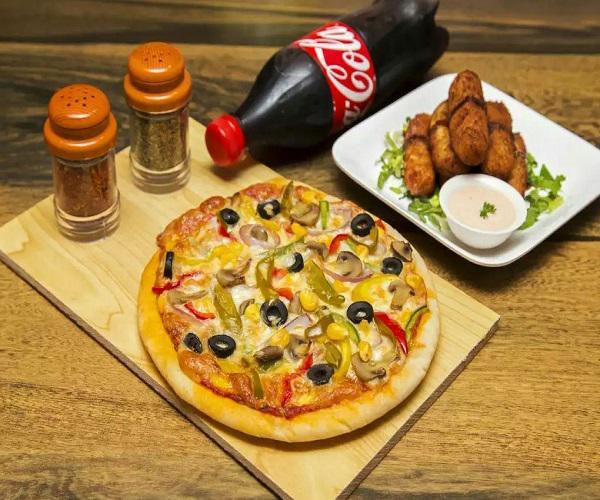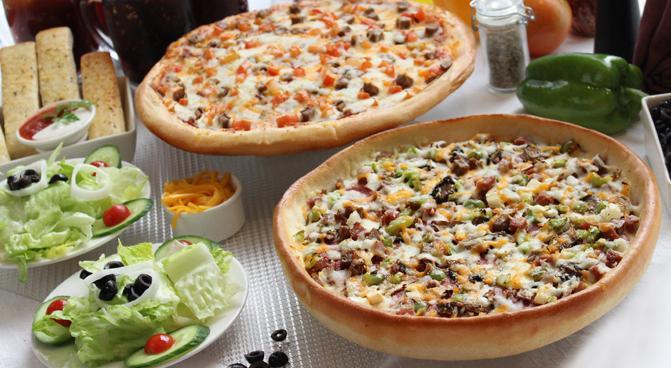The first image is the image on the left, the second image is the image on the right. Analyze the images presented: Is the assertion "An unopened container of soda is served with a pizza in one of the images." valid? Answer yes or no. Yes. The first image is the image on the left, the second image is the image on the right. Considering the images on both sides, is "One image includes salads on plates, a green bell pepper and a small white bowl of orange shredded cheese near two pizzas." valid? Answer yes or no. Yes. 